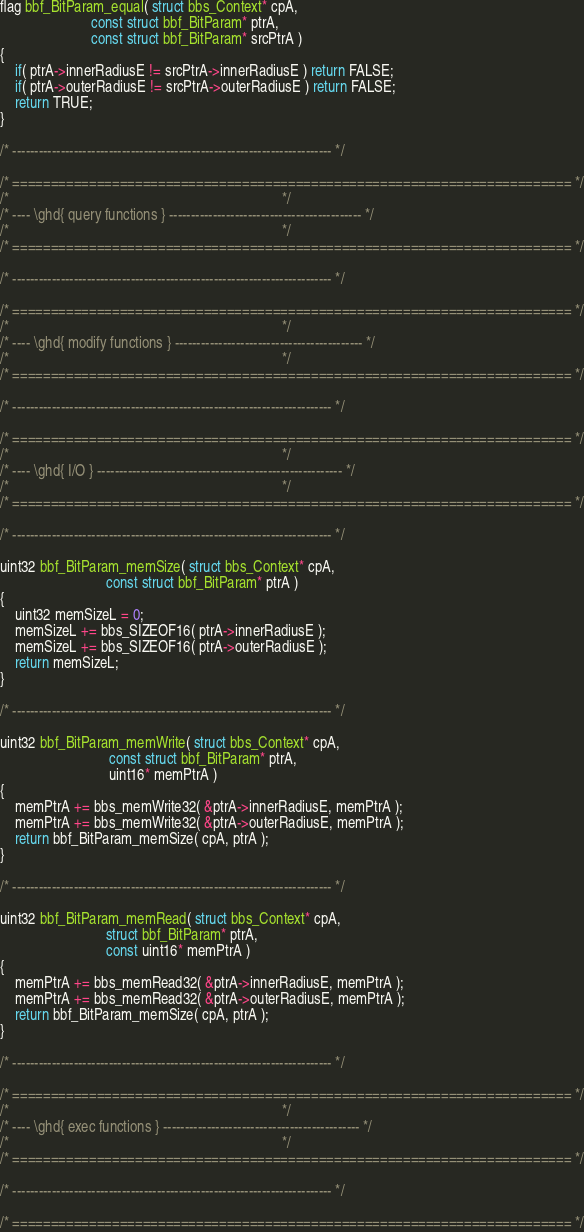Convert code to text. <code><loc_0><loc_0><loc_500><loc_500><_C_>flag bbf_BitParam_equal( struct bbs_Context* cpA,
					     const struct bbf_BitParam* ptrA, 
					     const struct bbf_BitParam* srcPtrA )
{
	if( ptrA->innerRadiusE != srcPtrA->innerRadiusE ) return FALSE;
	if( ptrA->outerRadiusE != srcPtrA->outerRadiusE ) return FALSE;
	return TRUE;
}

/* ------------------------------------------------------------------------- */

/* ========================================================================= */
/*                                                                           */
/* ---- \ghd{ query functions } -------------------------------------------- */
/*                                                                           */
/* ========================================================================= */

/* ------------------------------------------------------------------------- */

/* ========================================================================= */
/*                                                                           */
/* ---- \ghd{ modify functions } ------------------------------------------- */
/*                                                                           */
/* ========================================================================= */

/* ------------------------------------------------------------------------- */
	
/* ========================================================================= */
/*                                                                           */
/* ---- \ghd{ I/O } -------------------------------------------------------- */
/*                                                                           */
/* ========================================================================= */

/* ------------------------------------------------------------------------- */
	
uint32 bbf_BitParam_memSize( struct bbs_Context* cpA,
						     const struct bbf_BitParam* ptrA )
{
	uint32 memSizeL = 0; 
	memSizeL += bbs_SIZEOF16( ptrA->innerRadiusE );
	memSizeL += bbs_SIZEOF16( ptrA->outerRadiusE );
	return memSizeL; 
}

/* ------------------------------------------------------------------------- */
	
uint32 bbf_BitParam_memWrite( struct bbs_Context* cpA,
						      const struct bbf_BitParam* ptrA, 
							  uint16* memPtrA )
{
	memPtrA += bbs_memWrite32( &ptrA->innerRadiusE, memPtrA );
	memPtrA += bbs_memWrite32( &ptrA->outerRadiusE, memPtrA );
	return bbf_BitParam_memSize( cpA, ptrA );
}

/* ------------------------------------------------------------------------- */

uint32 bbf_BitParam_memRead( struct bbs_Context* cpA,
						     struct bbf_BitParam* ptrA, 
						     const uint16* memPtrA )
{
	memPtrA += bbs_memRead32( &ptrA->innerRadiusE, memPtrA );
	memPtrA += bbs_memRead32( &ptrA->outerRadiusE, memPtrA );
	return bbf_BitParam_memSize( cpA, ptrA );
}

/* ------------------------------------------------------------------------- */
	
/* ========================================================================= */
/*                                                                           */
/* ---- \ghd{ exec functions } --------------------------------------------- */
/*                                                                           */
/* ========================================================================= */
	
/* ------------------------------------------------------------------------- */

/* ========================================================================= */

</code> 